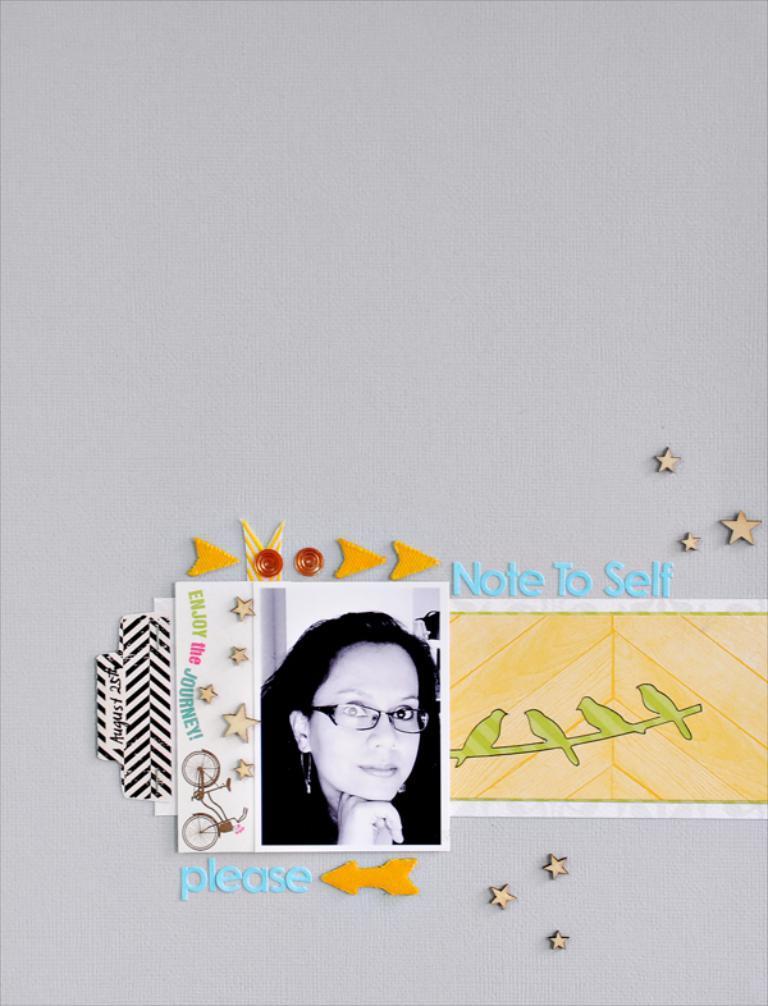Could you give a brief overview of what you see in this image? In this image, we can see some posts with images and text. We can see some crafted objects and the white background. 